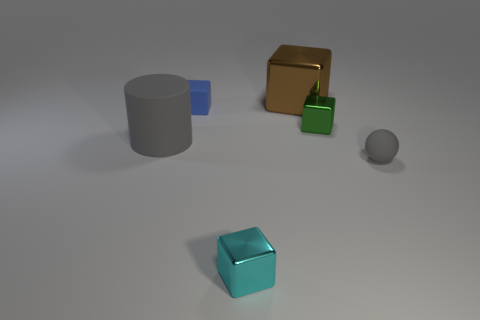What number of large rubber cylinders are the same color as the rubber sphere?
Ensure brevity in your answer.  1. Are any large gray matte objects visible?
Your response must be concise. Yes. Is the shape of the brown metal thing the same as the large object that is to the left of the tiny cyan cube?
Provide a succinct answer. No. The rubber object that is behind the gray rubber thing left of the small green metallic block behind the sphere is what color?
Ensure brevity in your answer.  Blue. Are there any large blocks in front of the brown cube?
Provide a short and direct response. No. The rubber thing that is the same color as the large rubber cylinder is what size?
Give a very brief answer. Small. Is there a tiny purple cylinder that has the same material as the small ball?
Make the answer very short. No. The large shiny cube has what color?
Offer a very short reply. Brown. There is a tiny rubber thing that is on the right side of the blue block; is its shape the same as the blue rubber thing?
Your answer should be compact. No. There is a gray rubber thing that is to the right of the shiny object behind the small rubber thing behind the green metal object; what is its shape?
Provide a short and direct response. Sphere. 